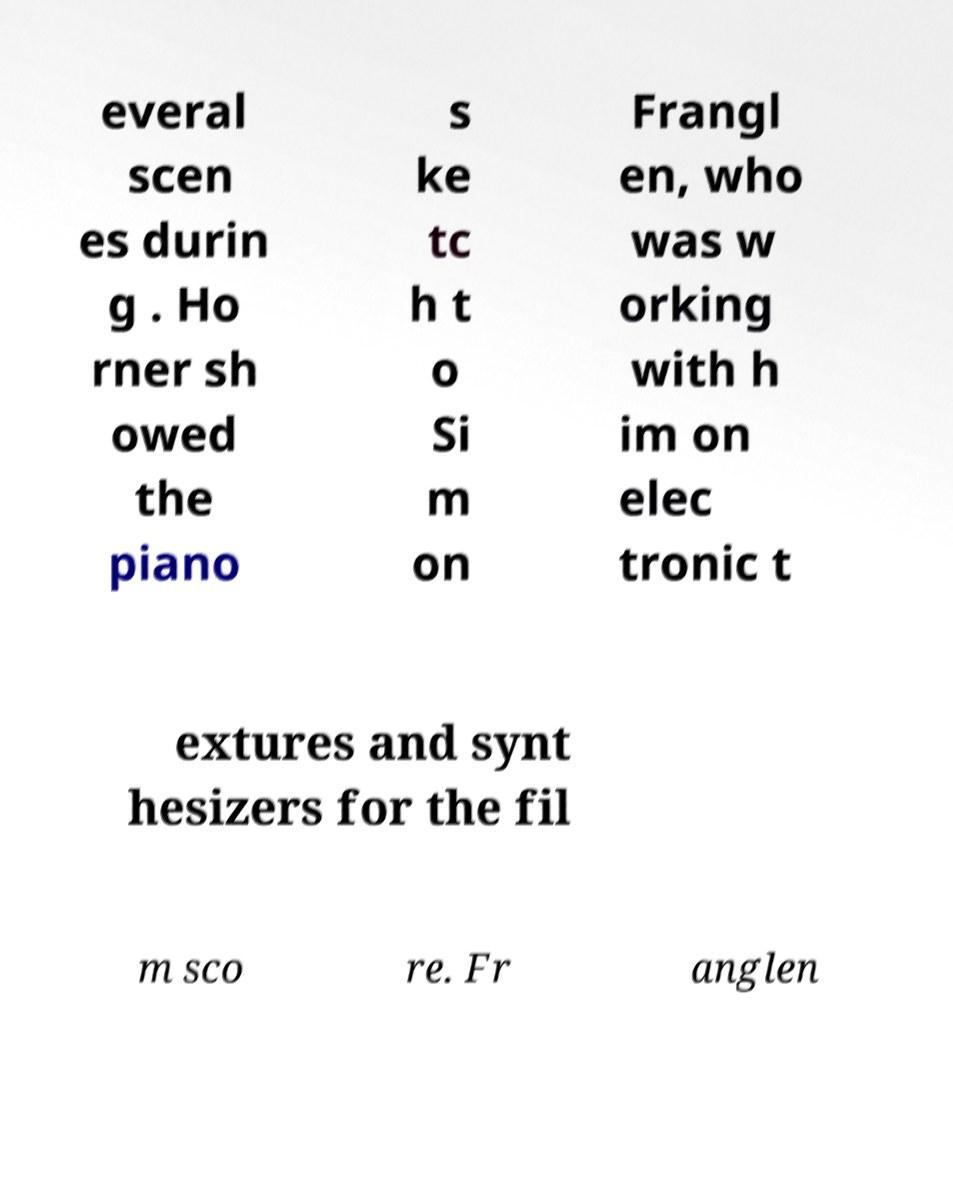Please identify and transcribe the text found in this image. everal scen es durin g . Ho rner sh owed the piano s ke tc h t o Si m on Frangl en, who was w orking with h im on elec tronic t extures and synt hesizers for the fil m sco re. Fr anglen 